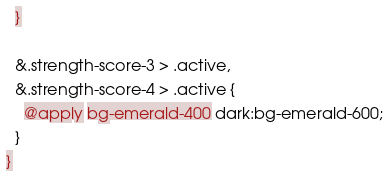<code> <loc_0><loc_0><loc_500><loc_500><_CSS_>  }

  &.strength-score-3 > .active,
  &.strength-score-4 > .active {
    @apply bg-emerald-400 dark:bg-emerald-600;
  }
}
</code> 